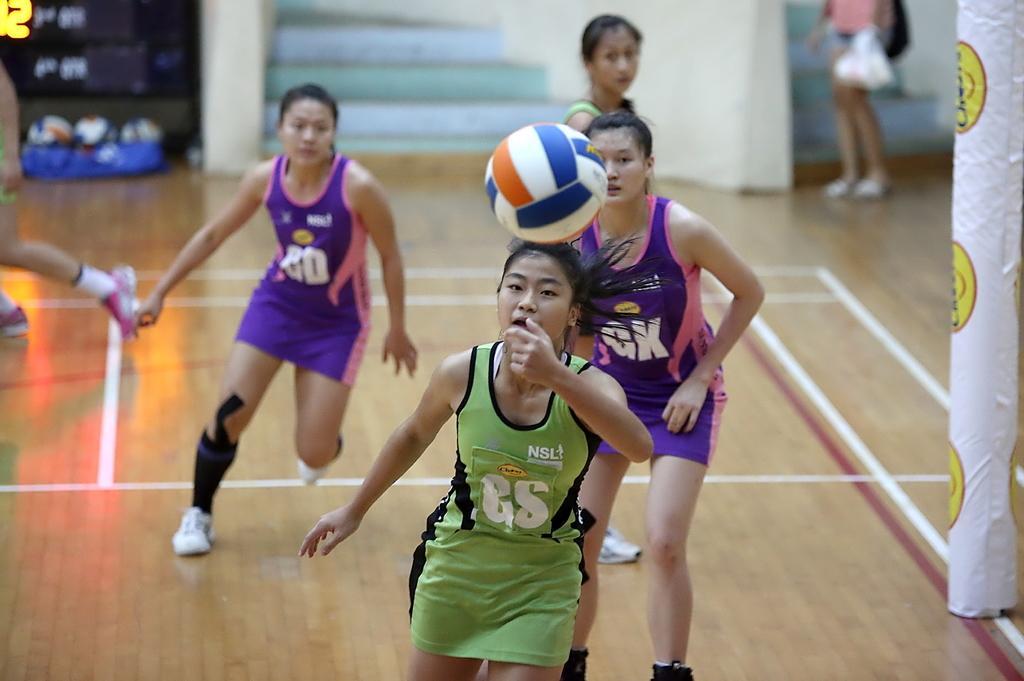Could you give a brief overview of what you see in this image? In this image we can see the women playing. We can also see the ball, score board and also the floor. We can also see the balls in the background. We can see a woman holding the cover and standing. On the right we can see a pole which is covered with the cloth. 